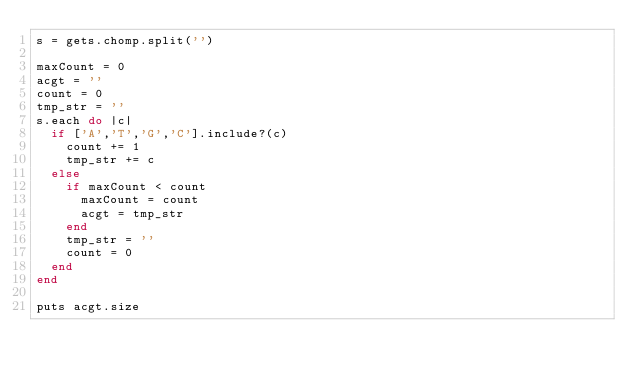Convert code to text. <code><loc_0><loc_0><loc_500><loc_500><_Ruby_>s = gets.chomp.split('')

maxCount = 0
acgt = ''
count = 0
tmp_str = ''
s.each do |c|
  if ['A','T','G','C'].include?(c)
    count += 1
    tmp_str += c
  else
    if maxCount < count
      maxCount = count
      acgt = tmp_str
    end
    tmp_str = ''
    count = 0
  end
end

puts acgt.size</code> 